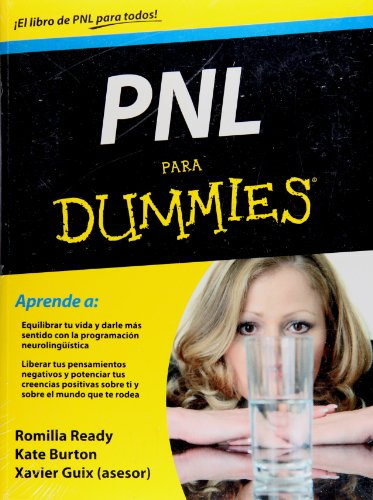What is the genre of this book? The genre of the book can be classified as Self-Help, specifically focusing on neurolinguistic programming, a personal development tool aimed at improving communication and personal growth. 